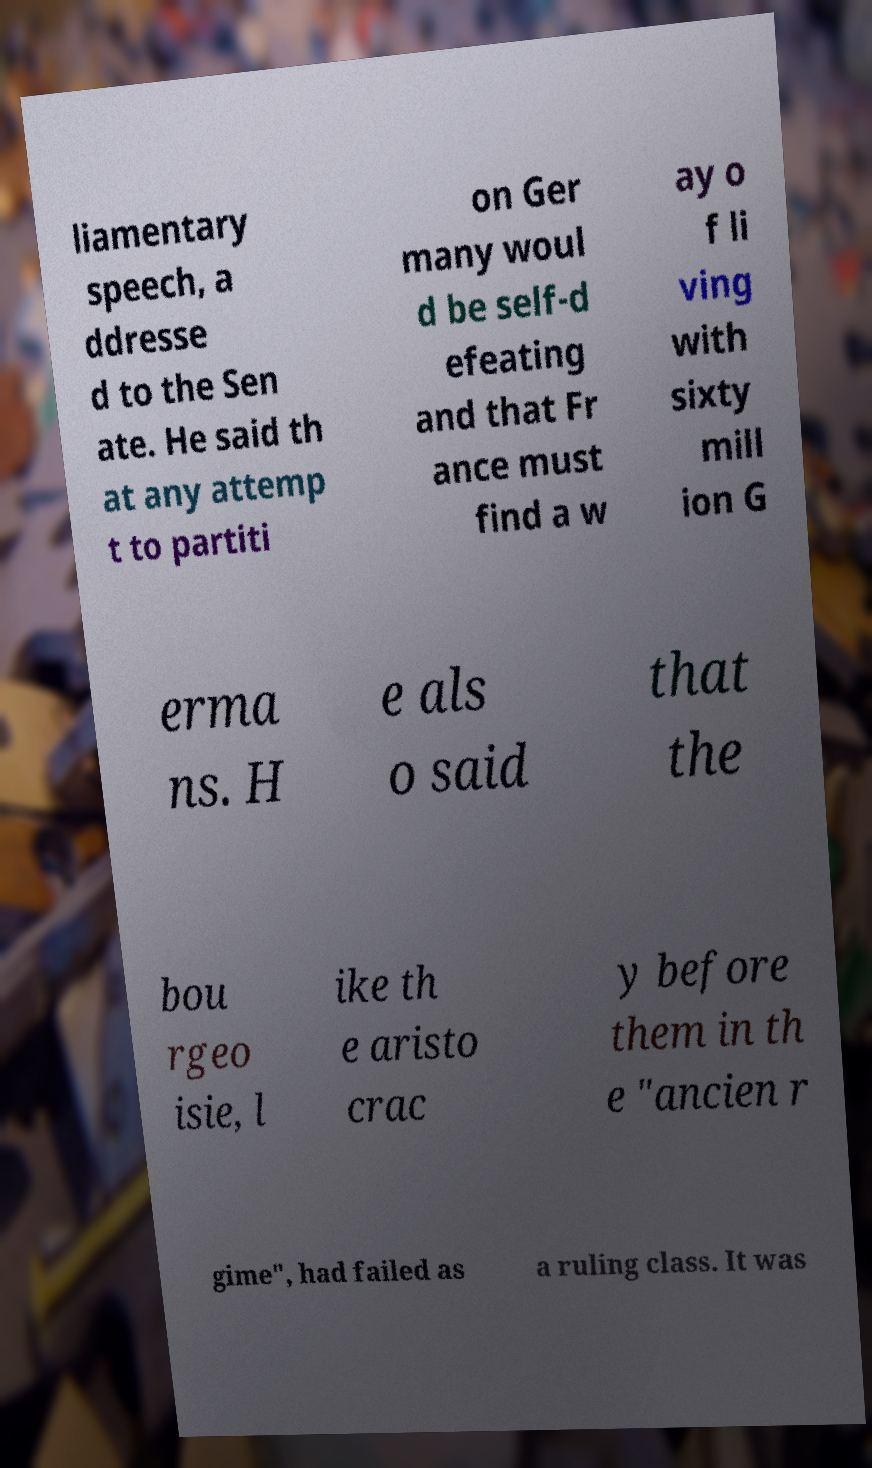Could you extract and type out the text from this image? liamentary speech, a ddresse d to the Sen ate. He said th at any attemp t to partiti on Ger many woul d be self-d efeating and that Fr ance must find a w ay o f li ving with sixty mill ion G erma ns. H e als o said that the bou rgeo isie, l ike th e aristo crac y before them in th e "ancien r gime", had failed as a ruling class. It was 